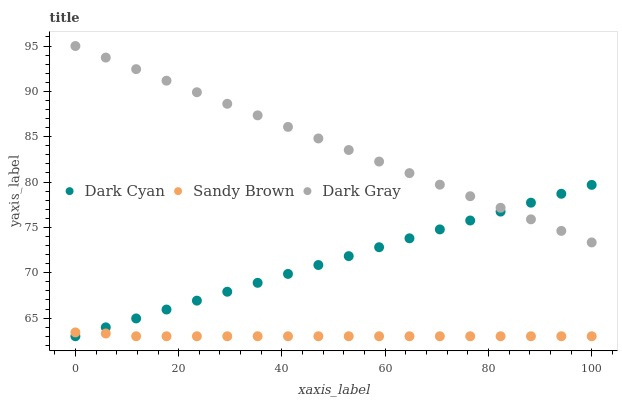Does Sandy Brown have the minimum area under the curve?
Answer yes or no. Yes. Does Dark Gray have the maximum area under the curve?
Answer yes or no. Yes. Does Dark Gray have the minimum area under the curve?
Answer yes or no. No. Does Sandy Brown have the maximum area under the curve?
Answer yes or no. No. Is Dark Cyan the smoothest?
Answer yes or no. Yes. Is Sandy Brown the roughest?
Answer yes or no. Yes. Is Dark Gray the smoothest?
Answer yes or no. No. Is Dark Gray the roughest?
Answer yes or no. No. Does Dark Cyan have the lowest value?
Answer yes or no. Yes. Does Dark Gray have the lowest value?
Answer yes or no. No. Does Dark Gray have the highest value?
Answer yes or no. Yes. Does Sandy Brown have the highest value?
Answer yes or no. No. Is Sandy Brown less than Dark Gray?
Answer yes or no. Yes. Is Dark Gray greater than Sandy Brown?
Answer yes or no. Yes. Does Dark Gray intersect Dark Cyan?
Answer yes or no. Yes. Is Dark Gray less than Dark Cyan?
Answer yes or no. No. Is Dark Gray greater than Dark Cyan?
Answer yes or no. No. Does Sandy Brown intersect Dark Gray?
Answer yes or no. No. 